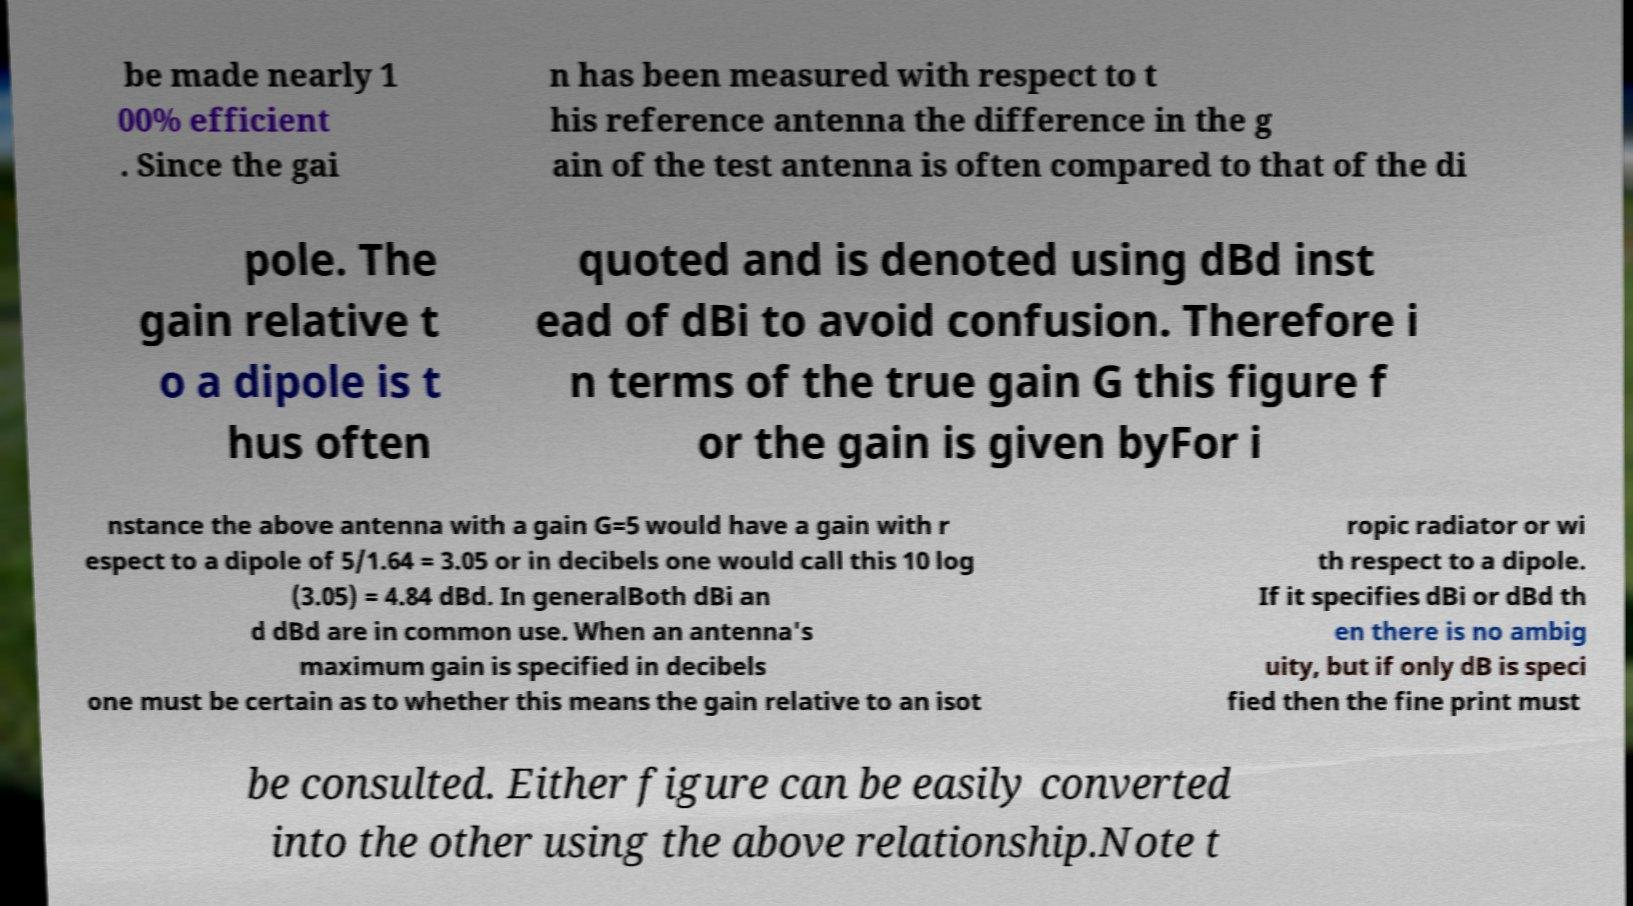Please read and relay the text visible in this image. What does it say? be made nearly 1 00% efficient . Since the gai n has been measured with respect to t his reference antenna the difference in the g ain of the test antenna is often compared to that of the di pole. The gain relative t o a dipole is t hus often quoted and is denoted using dBd inst ead of dBi to avoid confusion. Therefore i n terms of the true gain G this figure f or the gain is given byFor i nstance the above antenna with a gain G=5 would have a gain with r espect to a dipole of 5/1.64 = 3.05 or in decibels one would call this 10 log (3.05) = 4.84 dBd. In generalBoth dBi an d dBd are in common use. When an antenna's maximum gain is specified in decibels one must be certain as to whether this means the gain relative to an isot ropic radiator or wi th respect to a dipole. If it specifies dBi or dBd th en there is no ambig uity, but if only dB is speci fied then the fine print must be consulted. Either figure can be easily converted into the other using the above relationship.Note t 